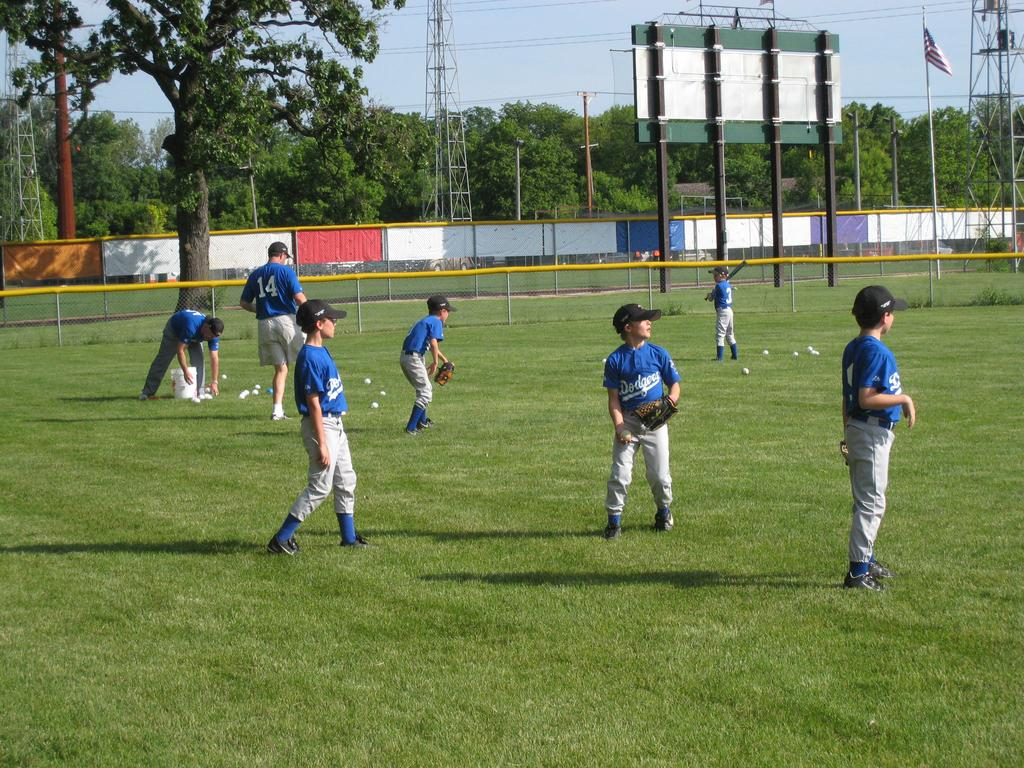<image>
Summarize the visual content of the image. Boys playing baseball on the field in blue Dodgers jerseys. 